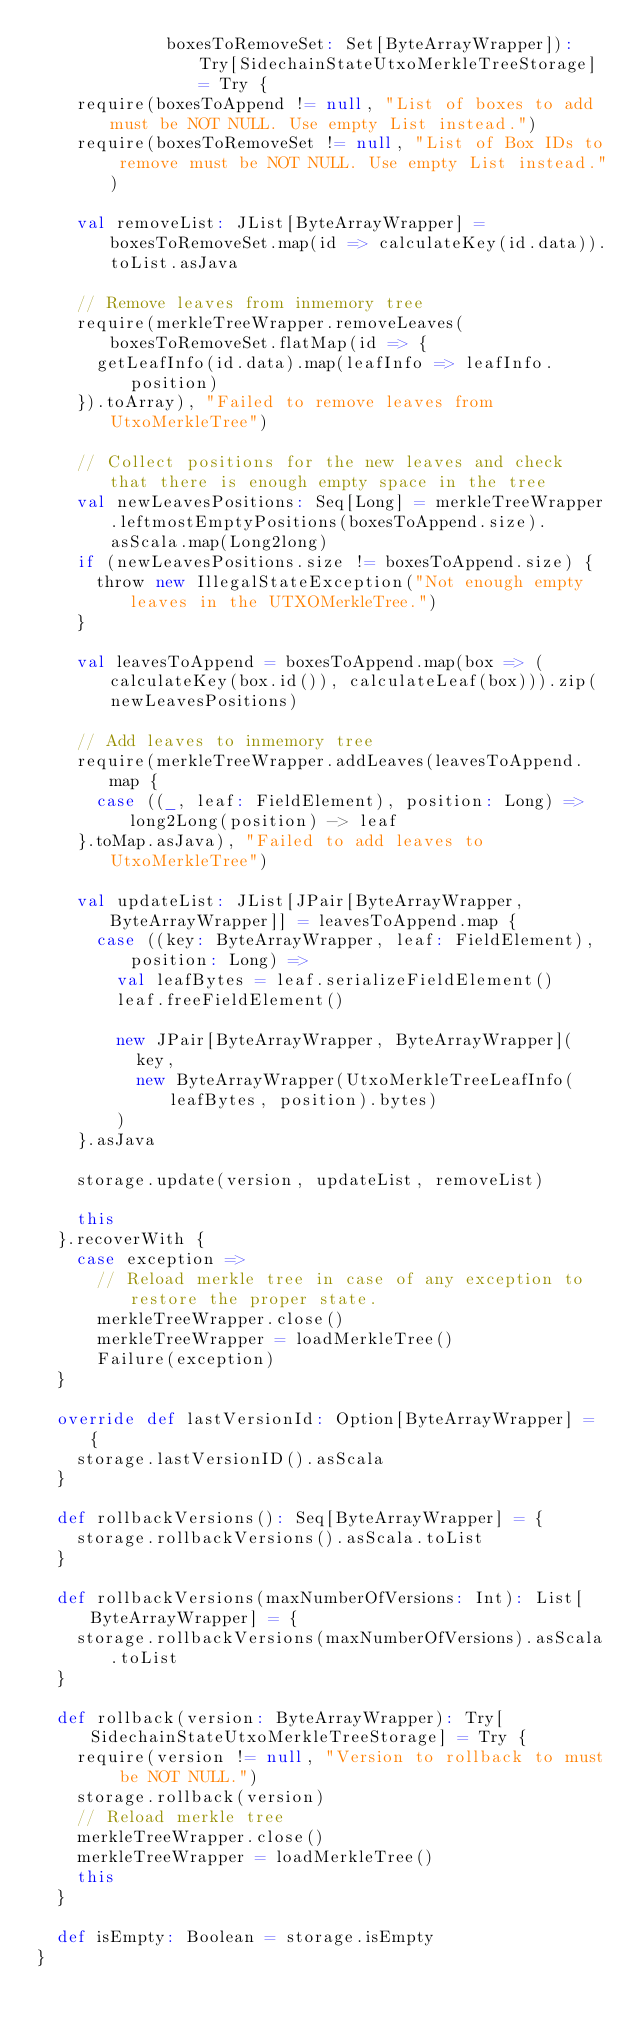Convert code to text. <code><loc_0><loc_0><loc_500><loc_500><_Scala_>             boxesToRemoveSet: Set[ByteArrayWrapper]): Try[SidechainStateUtxoMerkleTreeStorage] = Try {
    require(boxesToAppend != null, "List of boxes to add must be NOT NULL. Use empty List instead.")
    require(boxesToRemoveSet != null, "List of Box IDs to remove must be NOT NULL. Use empty List instead.")

    val removeList: JList[ByteArrayWrapper] = boxesToRemoveSet.map(id => calculateKey(id.data)).toList.asJava

    // Remove leaves from inmemory tree
    require(merkleTreeWrapper.removeLeaves(boxesToRemoveSet.flatMap(id => {
      getLeafInfo(id.data).map(leafInfo => leafInfo.position)
    }).toArray), "Failed to remove leaves from UtxoMerkleTree")

    // Collect positions for the new leaves and check that there is enough empty space in the tree
    val newLeavesPositions: Seq[Long] = merkleTreeWrapper.leftmostEmptyPositions(boxesToAppend.size).asScala.map(Long2long)
    if (newLeavesPositions.size != boxesToAppend.size) {
      throw new IllegalStateException("Not enough empty leaves in the UTXOMerkleTree.")
    }

    val leavesToAppend = boxesToAppend.map(box => (calculateKey(box.id()), calculateLeaf(box))).zip(newLeavesPositions)

    // Add leaves to inmemory tree
    require(merkleTreeWrapper.addLeaves(leavesToAppend.map {
      case ((_, leaf: FieldElement), position: Long) => long2Long(position) -> leaf
    }.toMap.asJava), "Failed to add leaves to UtxoMerkleTree")

    val updateList: JList[JPair[ByteArrayWrapper, ByteArrayWrapper]] = leavesToAppend.map {
      case ((key: ByteArrayWrapper, leaf: FieldElement), position: Long) =>
        val leafBytes = leaf.serializeFieldElement()
        leaf.freeFieldElement()

        new JPair[ByteArrayWrapper, ByteArrayWrapper](
          key,
          new ByteArrayWrapper(UtxoMerkleTreeLeafInfo(leafBytes, position).bytes)
        )
    }.asJava

    storage.update(version, updateList, removeList)

    this
  }.recoverWith {
    case exception =>
      // Reload merkle tree in case of any exception to restore the proper state.
      merkleTreeWrapper.close()
      merkleTreeWrapper = loadMerkleTree()
      Failure(exception)
  }

  override def lastVersionId: Option[ByteArrayWrapper] = {
    storage.lastVersionID().asScala
  }

  def rollbackVersions(): Seq[ByteArrayWrapper] = {
    storage.rollbackVersions().asScala.toList
  }

  def rollbackVersions(maxNumberOfVersions: Int): List[ByteArrayWrapper] = {
    storage.rollbackVersions(maxNumberOfVersions).asScala.toList
  }

  def rollback(version: ByteArrayWrapper): Try[SidechainStateUtxoMerkleTreeStorage] = Try {
    require(version != null, "Version to rollback to must be NOT NULL.")
    storage.rollback(version)
    // Reload merkle tree
    merkleTreeWrapper.close()
    merkleTreeWrapper = loadMerkleTree()
    this
  }

  def isEmpty: Boolean = storage.isEmpty
}
</code> 